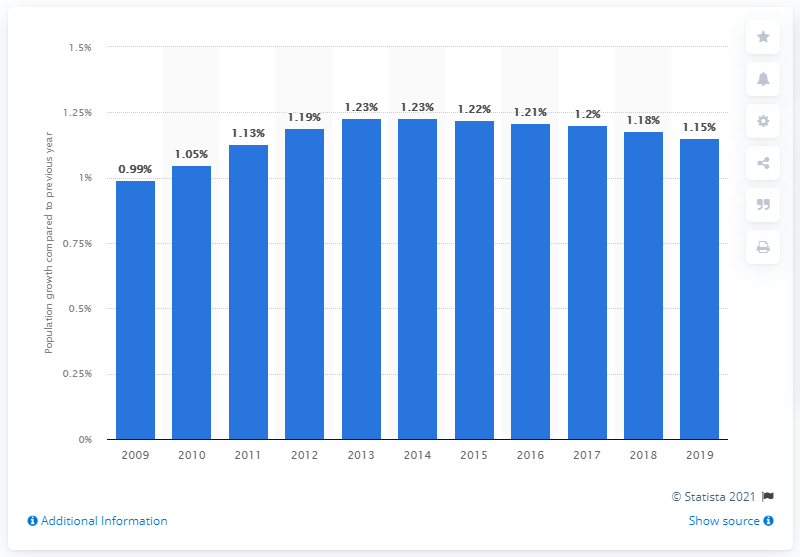List a handful of essential elements in this visual. According to sources, the population of Bhutan increased by 1.15% in 2019. 